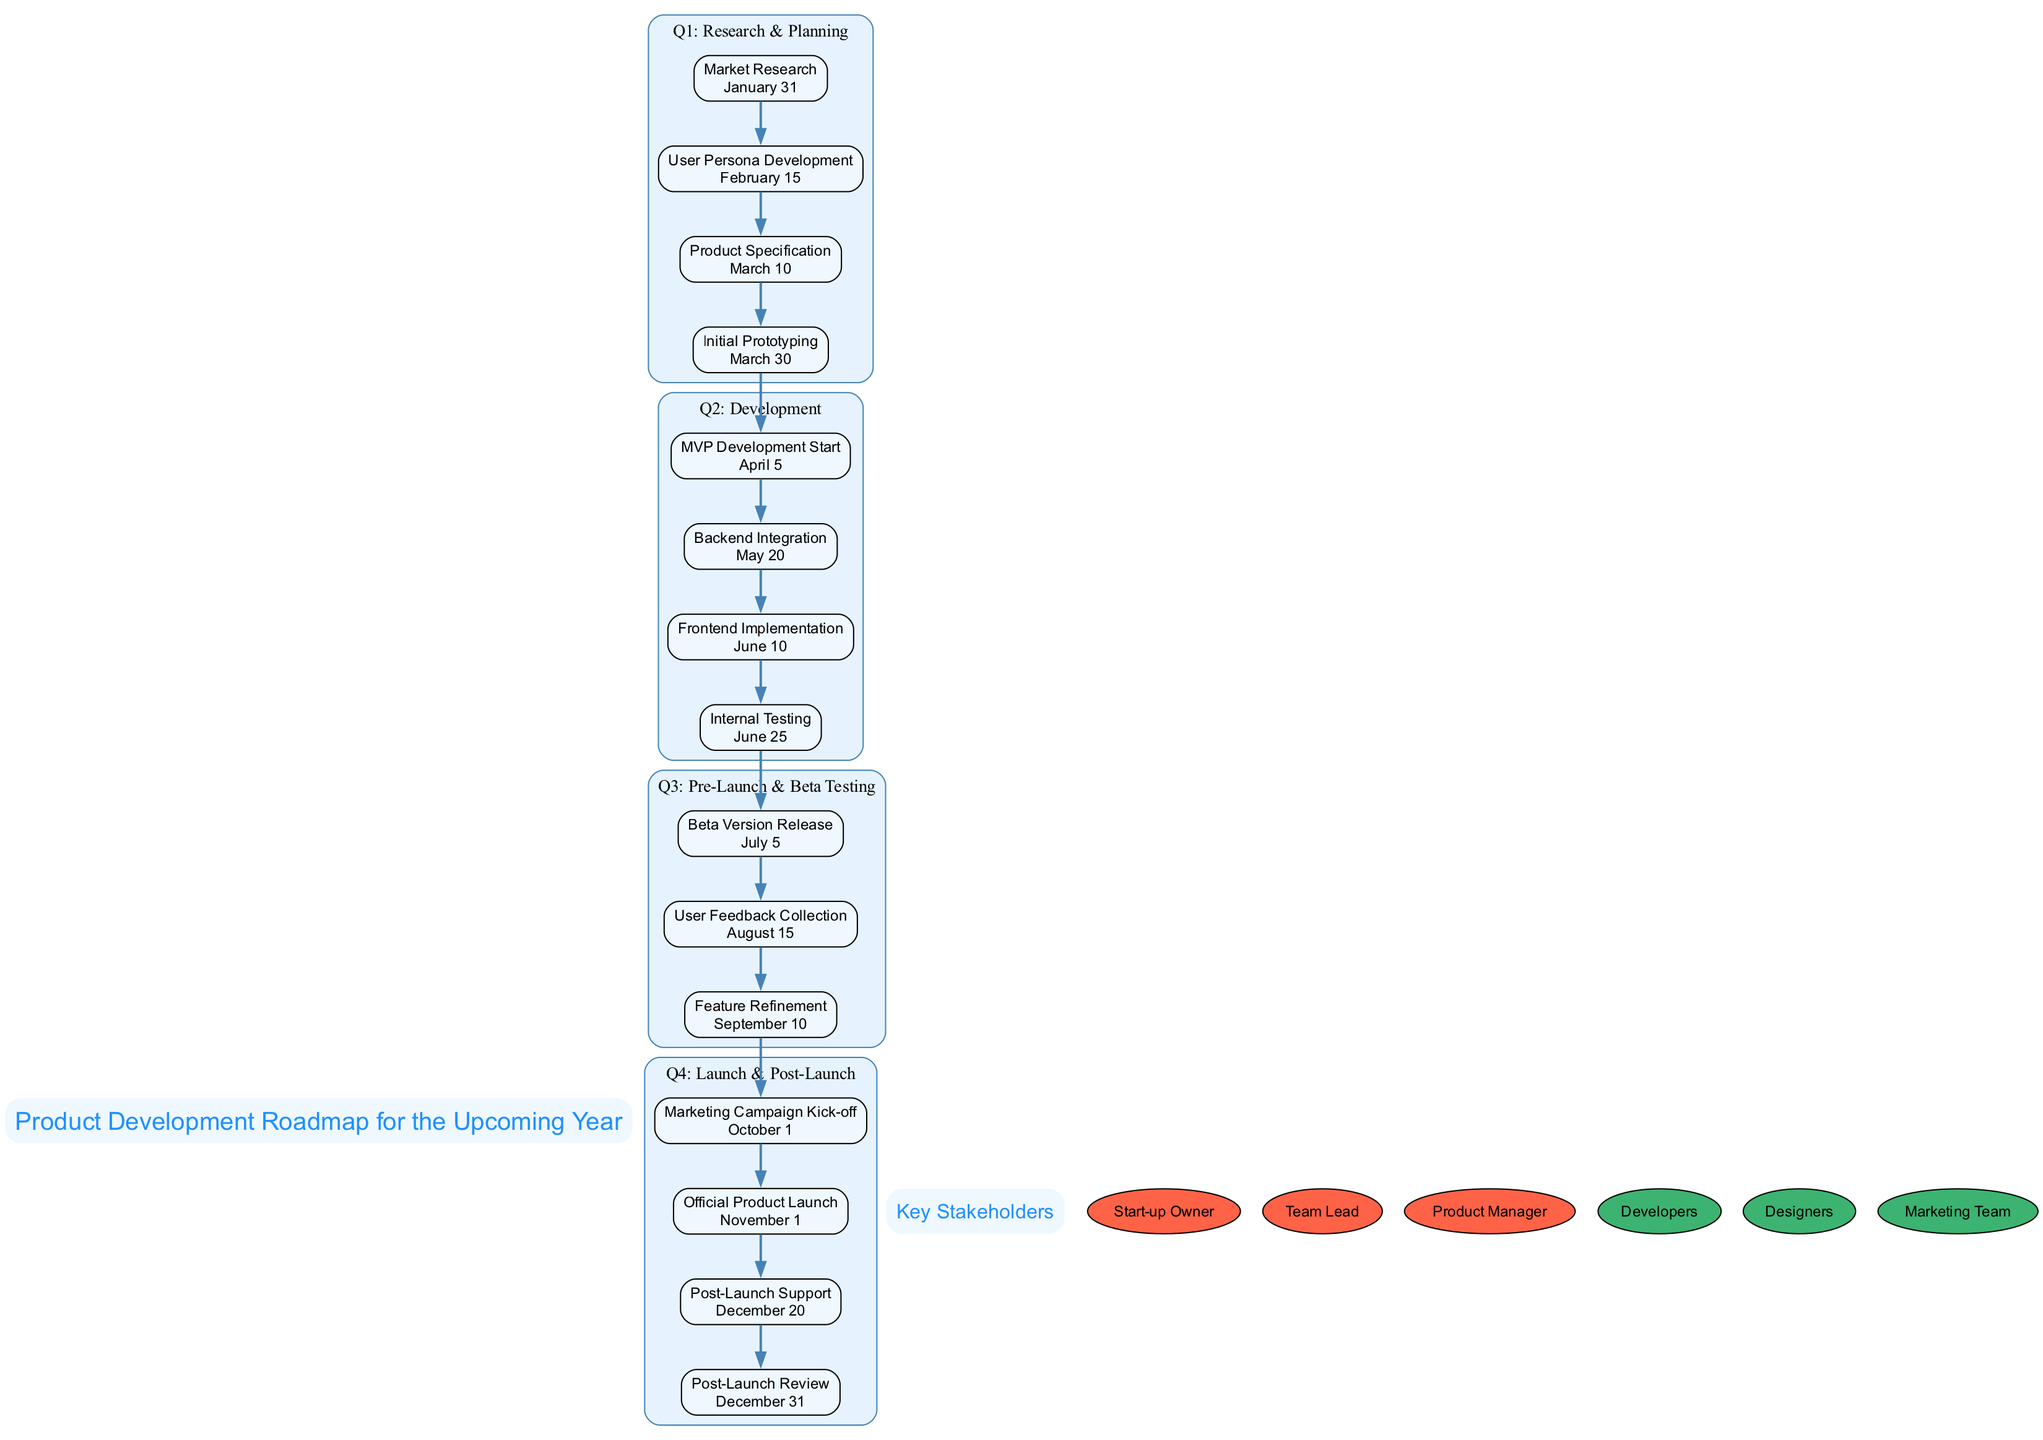What is the deadline for Market Research? The milestone 'Market Research' is located in the 'Q1: Research & Planning' phase. The associated deadline for this milestone, as indicated in the diagram, is 'January 31'.
Answer: January 31 How many milestones are there in Q2: Development? In the 'Q2: Development' phase, there are four milestones: 'MVP Development Start', 'Backend Integration', 'Frontend Implementation', and 'Internal Testing'. Counting these gives a total of four milestones.
Answer: 4 Which milestone comes immediately after the Beta Version Release? The 'Beta Version Release' is scheduled for 'July 5' in the 'Q3: Pre-Launch & Beta Testing' phase. The next milestone listed after this is 'User Feedback Collection', scheduled for 'August 15'.
Answer: User Feedback Collection What is the last milestone in the Q4: Launch & Post-Launch phase? In the 'Q4: Launch & Post-Launch' phase, the milestones are 'Marketing Campaign Kick-off', 'Official Product Launch', 'Post-Launch Support', and 'Post-Launch Review'. The last milestone listed is 'Post-Launch Review'.
Answer: Post-Launch Review How many total milestones are planned for the year? By reviewing all the phases, the milestones include those in Q1 (4), Q2 (4), Q3 (3), and Q4 (4), totaling 4 + 4 + 3 + 4 = 15 milestones planned throughout the year.
Answer: 15 What is the importance level of the Marketing Team? The 'Marketing Team' is listed among the key stakeholders, and its importance is colored in medium. This indicates that its importance level is 'Medium'.
Answer: Medium Which phase includes Internal Testing? The milestone 'Internal Testing' occurs in the 'Q2: Development' phase, which indicates that it is part of the development process leading up to internal examination before launch.
Answer: Q2: Development When does Post-Launch Support start? The milestone 'Post-Launch Support' occurs in the 'Q4: Launch & Post-Launch' phase, and its deadline is set for 'December 20'. Therefore, it starts on 'December 20'.
Answer: December 20 Which role has a high importance level and is responsible for product management? Among the roles listed, 'Product Manager' is categorized with a high importance level. This indicates its significant responsibility in the roadmap.
Answer: Product Manager 